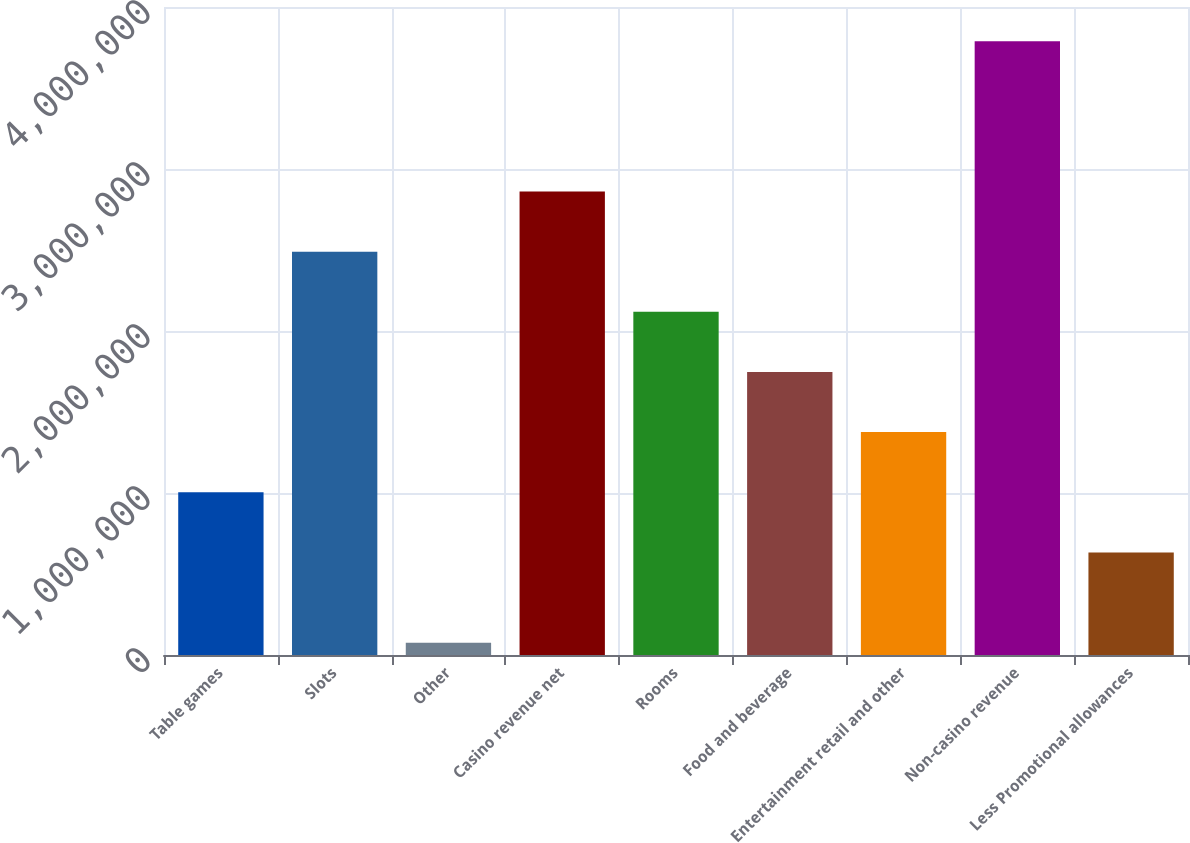Convert chart to OTSL. <chart><loc_0><loc_0><loc_500><loc_500><bar_chart><fcel>Table games<fcel>Slots<fcel>Other<fcel>Casino revenue net<fcel>Rooms<fcel>Food and beverage<fcel>Entertainment retail and other<fcel>Non-casino revenue<fcel>Less Promotional allowances<nl><fcel>1.00452e+06<fcel>2.48971e+06<fcel>74915<fcel>2.861e+06<fcel>2.11841e+06<fcel>1.74711e+06<fcel>1.37582e+06<fcel>3.78788e+06<fcel>633225<nl></chart> 